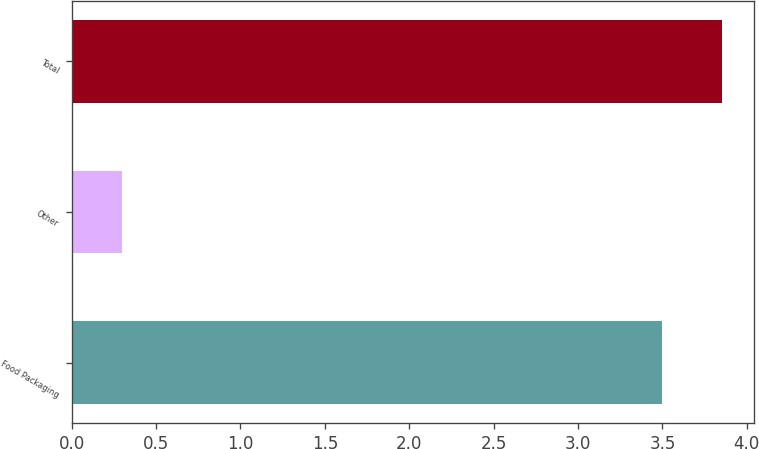Convert chart to OTSL. <chart><loc_0><loc_0><loc_500><loc_500><bar_chart><fcel>Food Packaging<fcel>Other<fcel>Total<nl><fcel>3.5<fcel>0.3<fcel>3.85<nl></chart> 